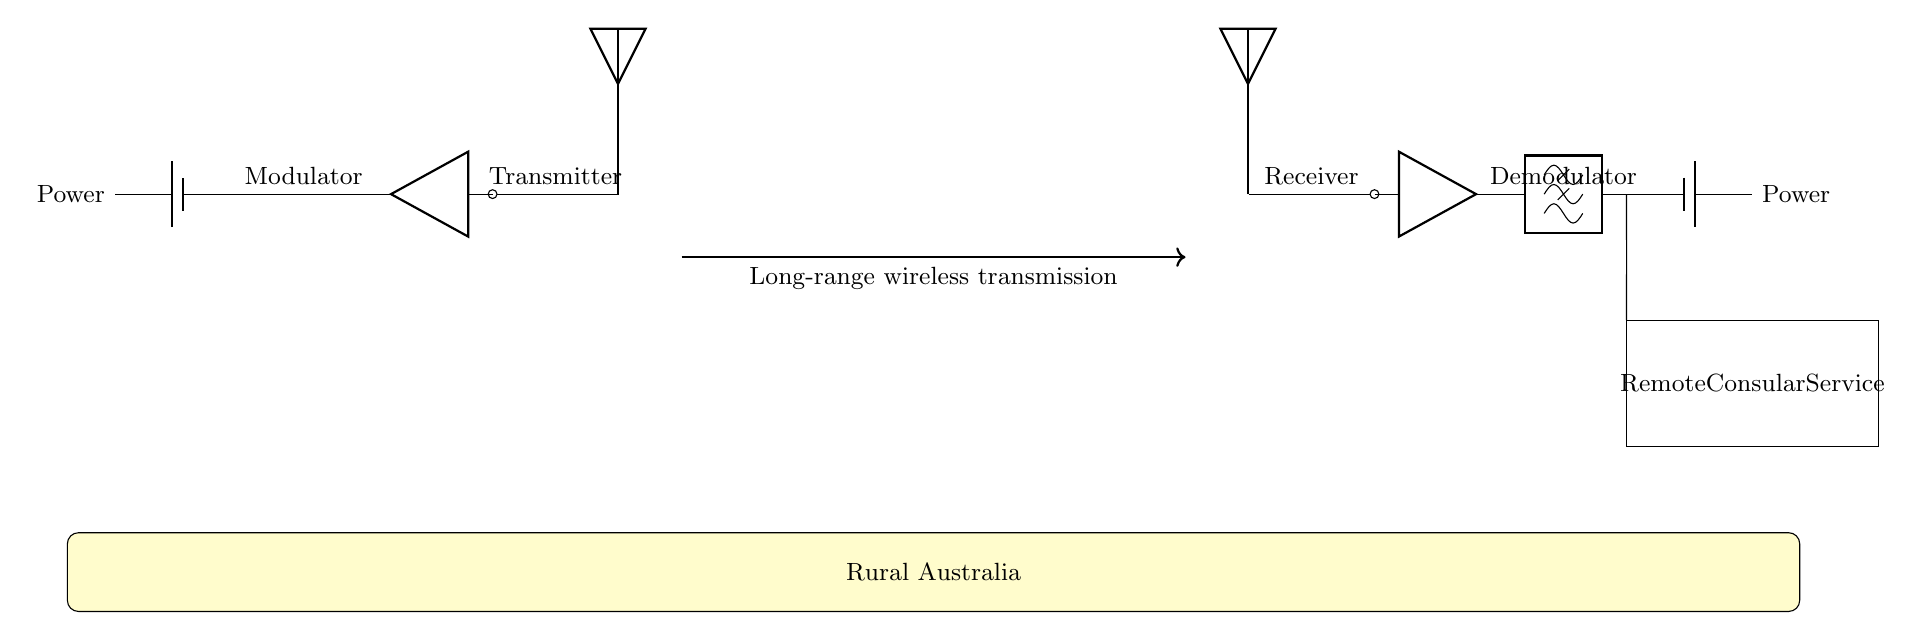What type of transmission is used in this circuit? The circuit utilizes long-range wireless transmission, as indicated by the arrow labeled with that phrase between the transmitter and receiver.
Answer: Long-range wireless transmission What components are part of the transmitter? The transmitter includes an antenna, amplifier, modulator, and power source (battery). Each component is clearly labeled in the diagram.
Answer: Antenna, amplifier, modulator, battery What is the purpose of the lowpass filter in the receiver? The lowpass filter in the receiver is used to remove unwanted high-frequency signals, allowing only the desired lower frequency signals to pass through. This is critical for accurately receiving modulated signals.
Answer: To remove unwanted high-frequency signals How does power supply to the components work? Each component in both the transmitter and receiver sections is connected to a battery, indicating that they rely on this power source for operation. Thus, both sections have independent power supplies.
Answer: Each section has a battery What function does the modulator serve in the transmitter? The modulator's function is to encode the information signal onto a carrier wave, which allows it to be transmitted over a long distance. This modulation is essential for effective communication.
Answer: To encode the information signal What is the significance of the yellow box labeled "Rural Australia"? The yellow box indicates the target area of the setup, emphasizing that the system is designed for remote consular services in rural locations, which often lack reliable communication infrastructure.
Answer: Target area for the service 